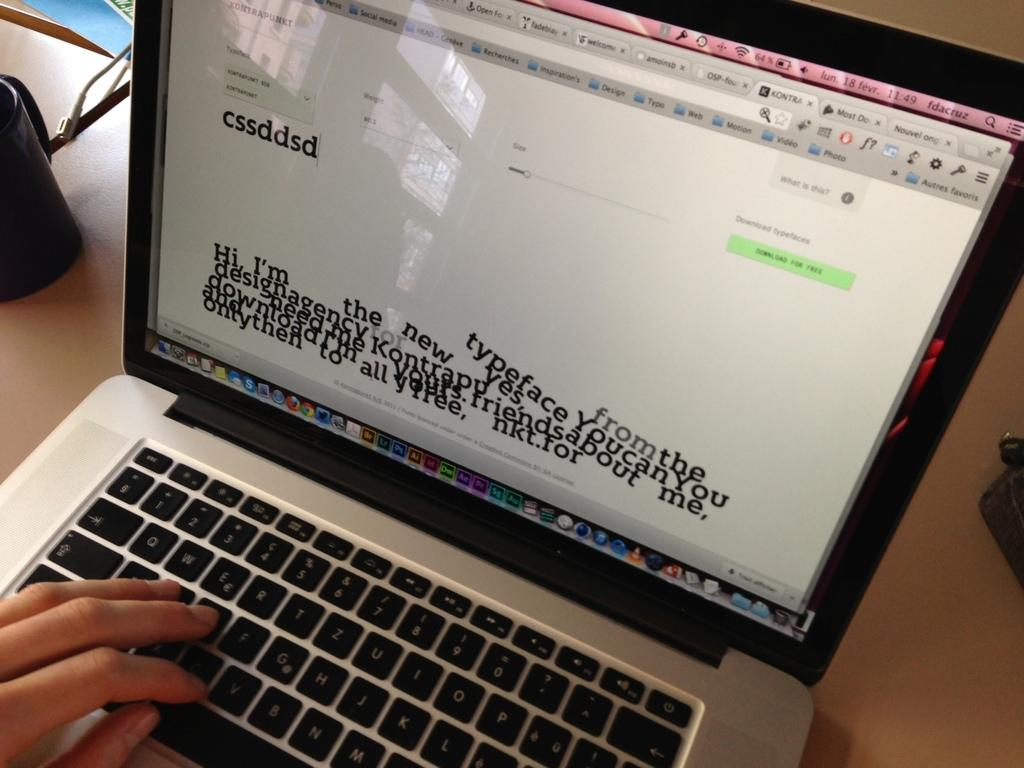<image>
Offer a succinct explanation of the picture presented. A laptop with the letters cssdsd typed out and the word typeface toward the bottom. 